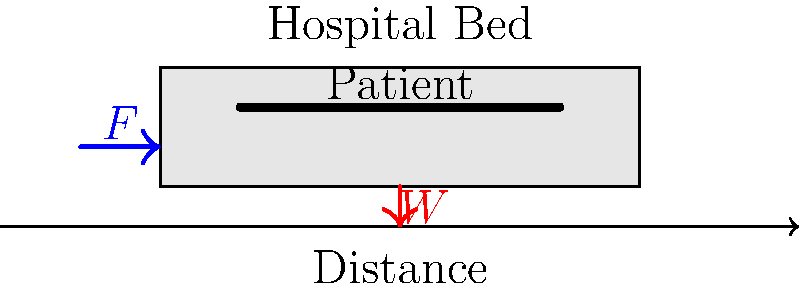A hospital bed with a patient needs to be moved along a horizontal floor. The total mass of the bed and patient is 180 kg, and the coefficient of friction between the bed wheels and the floor is 0.1. What minimum force F (in Newtons) is required to start moving the bed? To solve this problem, we'll follow these steps:

1) First, we need to identify the forces acting on the bed:
   - Weight (W) of the bed and patient
   - Normal force (N) from the floor
   - Friction force (f)
   - Applied force (F)

2) The weight and normal force cancel out since the bed is on a horizontal surface:
   $W = N = mg$, where $m$ is the mass and $g$ is the acceleration due to gravity (9.8 m/s²)

3) The friction force is given by:
   $f = \mu N$, where $\mu$ is the coefficient of friction

4) For the bed to start moving, the applied force must be equal to or greater than the friction force:
   $F \geq f$

5) Let's calculate the normal force:
   $N = mg = 180 \text{ kg} \times 9.8 \text{ m/s²} = 1764 \text{ N}$

6) Now, we can calculate the friction force:
   $f = \mu N = 0.1 \times 1764 \text{ N} = 176.4 \text{ N}$

7) Therefore, the minimum force required to start moving the bed is:
   $F = 176.4 \text{ N}$

This force overcomes the static friction and will initiate the movement of the bed.
Answer: 176.4 N 